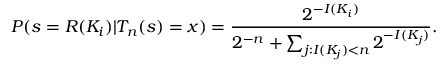Convert formula to latex. <formula><loc_0><loc_0><loc_500><loc_500>P ( s = R ( K _ { i } ) | T _ { n } ( s ) = x ) = { \frac { 2 ^ { - I ( K _ { i } ) } } { 2 ^ { - n } + \sum _ { j \colon I ( K _ { j } ) < n } 2 ^ { - I ( K _ { j } ) } } } .</formula> 